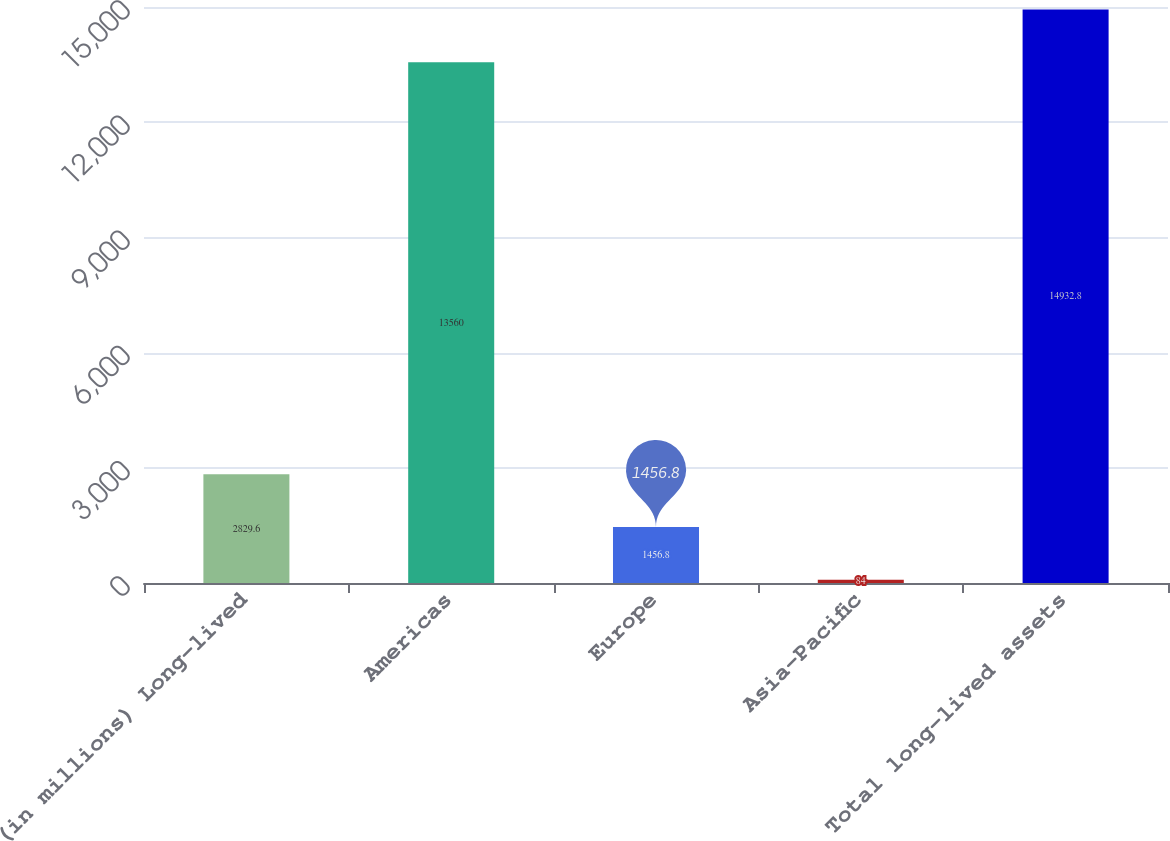Convert chart. <chart><loc_0><loc_0><loc_500><loc_500><bar_chart><fcel>(in millions) Long-lived<fcel>Americas<fcel>Europe<fcel>Asia-Pacific<fcel>Total long-lived assets<nl><fcel>2829.6<fcel>13560<fcel>1456.8<fcel>84<fcel>14932.8<nl></chart> 